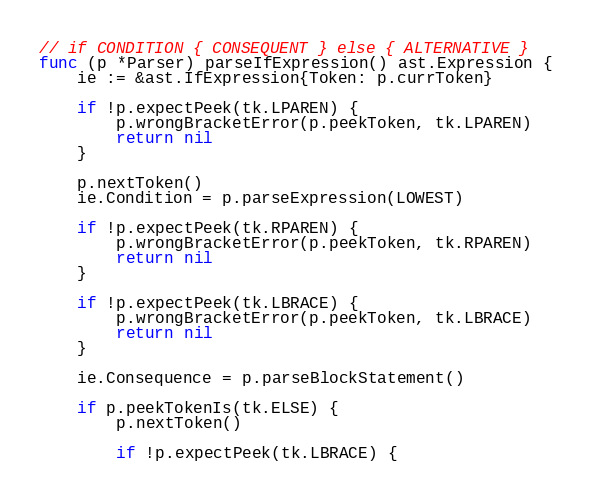Convert code to text. <code><loc_0><loc_0><loc_500><loc_500><_Go_>
// if CONDITION { CONSEQUENT } else { ALTERNATIVE }
func (p *Parser) parseIfExpression() ast.Expression {
	ie := &ast.IfExpression{Token: p.currToken}

	if !p.expectPeek(tk.LPAREN) {
		p.wrongBracketError(p.peekToken, tk.LPAREN)
		return nil
	}

	p.nextToken()
	ie.Condition = p.parseExpression(LOWEST)

	if !p.expectPeek(tk.RPAREN) {
		p.wrongBracketError(p.peekToken, tk.RPAREN)
		return nil
	}

	if !p.expectPeek(tk.LBRACE) {
		p.wrongBracketError(p.peekToken, tk.LBRACE)
		return nil
	}

	ie.Consequence = p.parseBlockStatement()

	if p.peekTokenIs(tk.ELSE) {
		p.nextToken()

		if !p.expectPeek(tk.LBRACE) {</code> 